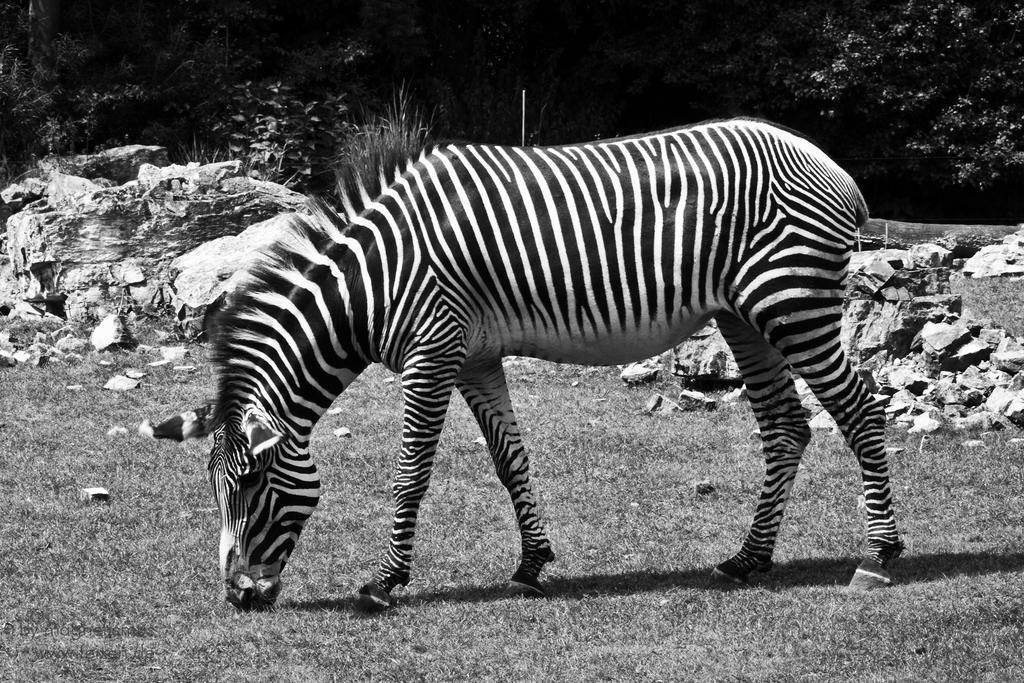What animal is present in the picture? There is a zebra in the picture. What is the zebra doing in the picture? The zebra is grazing grass. What can be seen in the background of the picture? There are rocks and trees in the background of the picture. What type of mask is the zebra wearing in the picture? There is no mask present on the zebra in the image. How much money is the zebra holding in the picture? There is no money or any indication of currency in the image. 